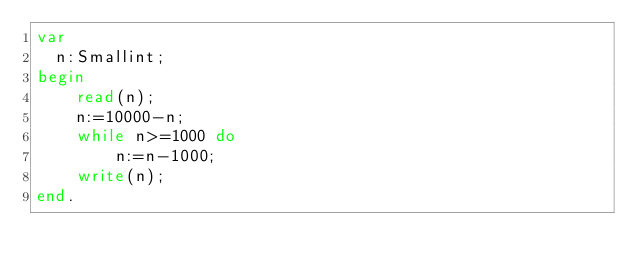Convert code to text. <code><loc_0><loc_0><loc_500><loc_500><_Pascal_>var
	n:Smallint;
begin
    read(n);
    n:=10000-n;
    while n>=1000 do
        n:=n-1000;
    write(n);
end.</code> 